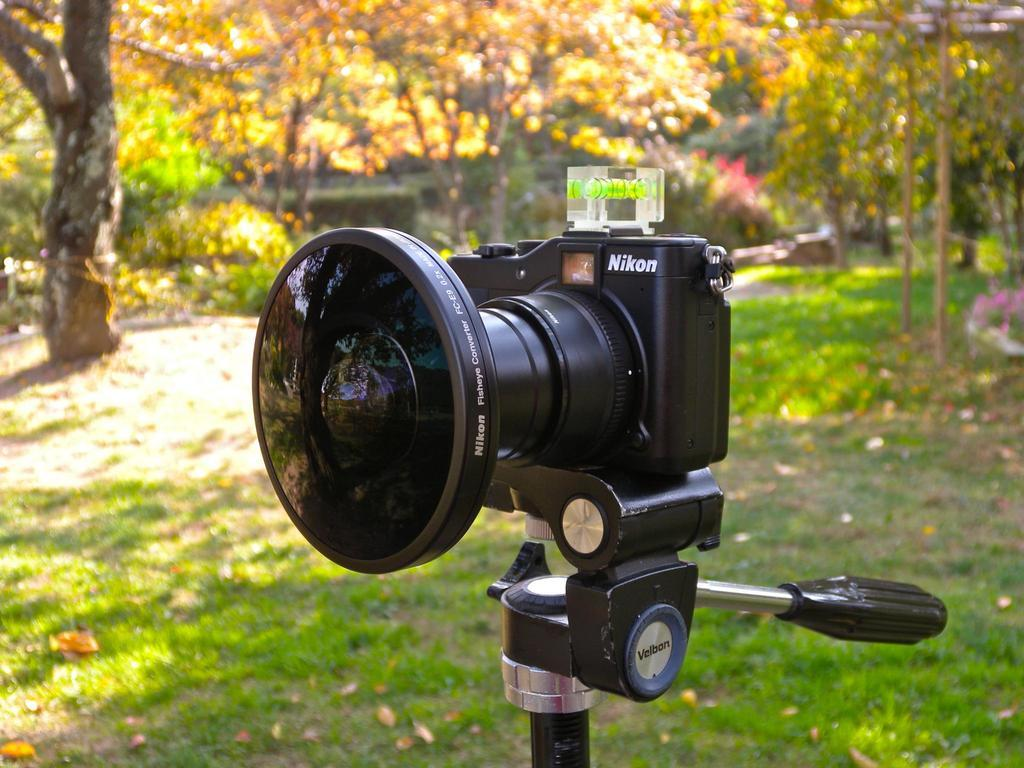What is the main subject of the image? There is a camera in the center of the image. What can be seen in the background of the image? There are trees in the background of the image. How does the camera twist in the image? The camera does not twist in the image; it is stationary and facing forward. What type of beast can be seen hiding behind the trees in the image? There are no beasts present in the image; it only features a camera and trees in the background. 